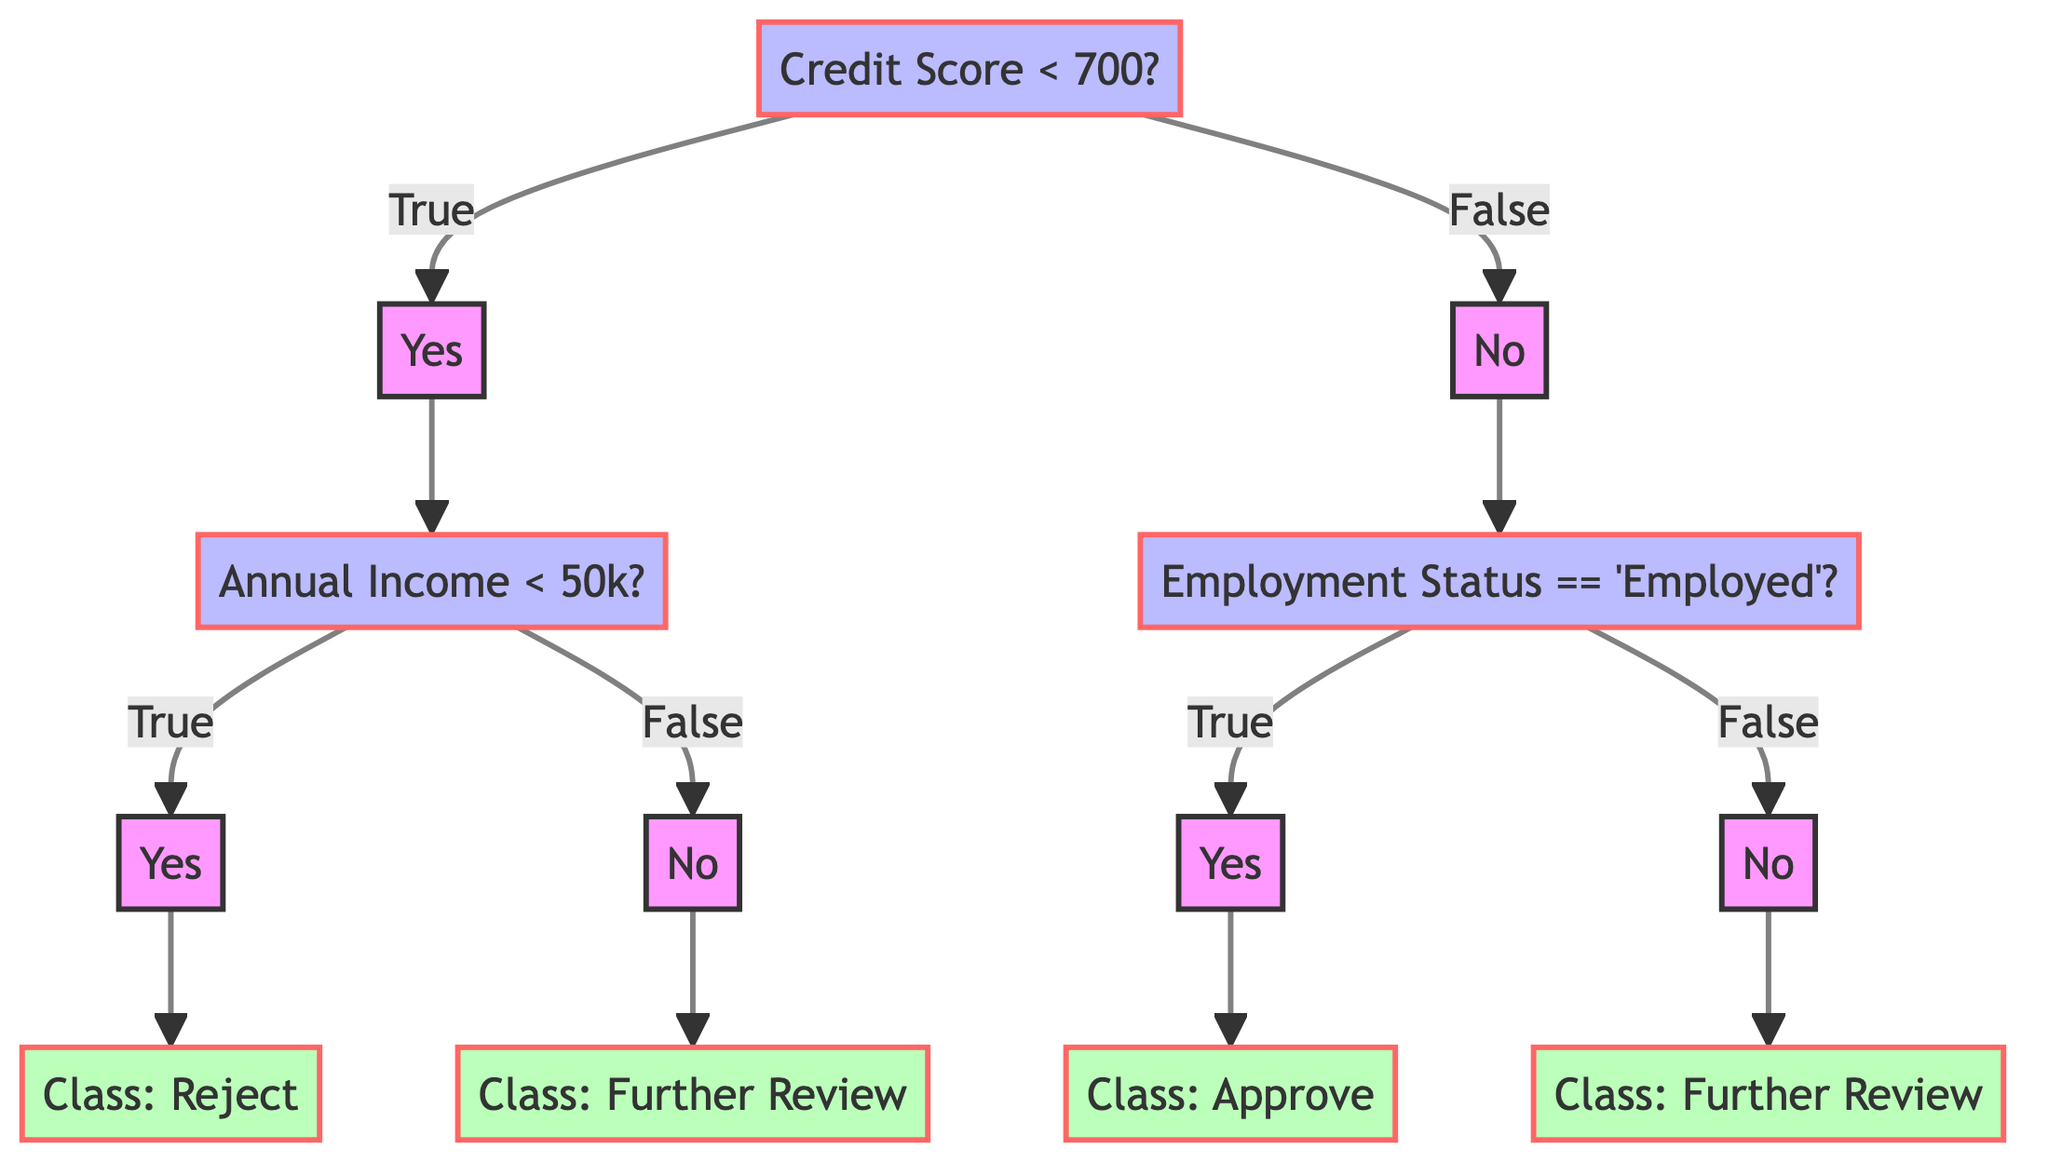What is the first decision node in the diagram? The first decision node is labeled "Credit Score < 700?" which determines the initial path.
Answer: Credit Score < 700? How many leaf nodes are present in the diagram? The diagram has four outcome leaf nodes which represent the final classification results.
Answer: 4 What class does the leftmost leaf node represent? The leftmost leaf node is labeled "Class: Reject," indicating a rejection outcome based on the criteria in the decision tree.
Answer: Class: Reject What decision follows the 'No' path from the root node? The 'No' path from the root leads to the decision node labeled "Employment Status == 'Employed'?" which assesses employment status next.
Answer: Employment Status == 'Employed'? What is the classification outcome if someone has a credit score under 700 and an annual income over 50k? Based on the path, if a user has a credit score under 700 leading to the first 'Yes' and an 'Income over 50k' leading to 'No', the outcome is "Class: Further Review."
Answer: Class: Further Review What are the conditions leading to the "Class: Approve" outcome? To reach "Class: Approve," the path requires a 'No' response from the root and a 'Yes' response for the 'Employment Status == 'Employed'? decision.
Answer: Class: Approve How many total decision nodes are displayed in the diagram? There are three decision nodes in the diagram that determine the classification steps and conditions based on user input.
Answer: 3 What condition must be true for the left subtree of the diagram to be followed? For the left subtree to be followed, the condition "Credit Score < 700?" must be true, leading to further classification questions.
Answer: Credit Score < 700? What does the right child node of the decision labeled ‘Employment Status == 'Employed'?’ classify as? The right child node of 'Employment Status == 'Employed'?' leads to "Class: Further Review", indicating a second classification action if not employed.
Answer: Class: Further Review 